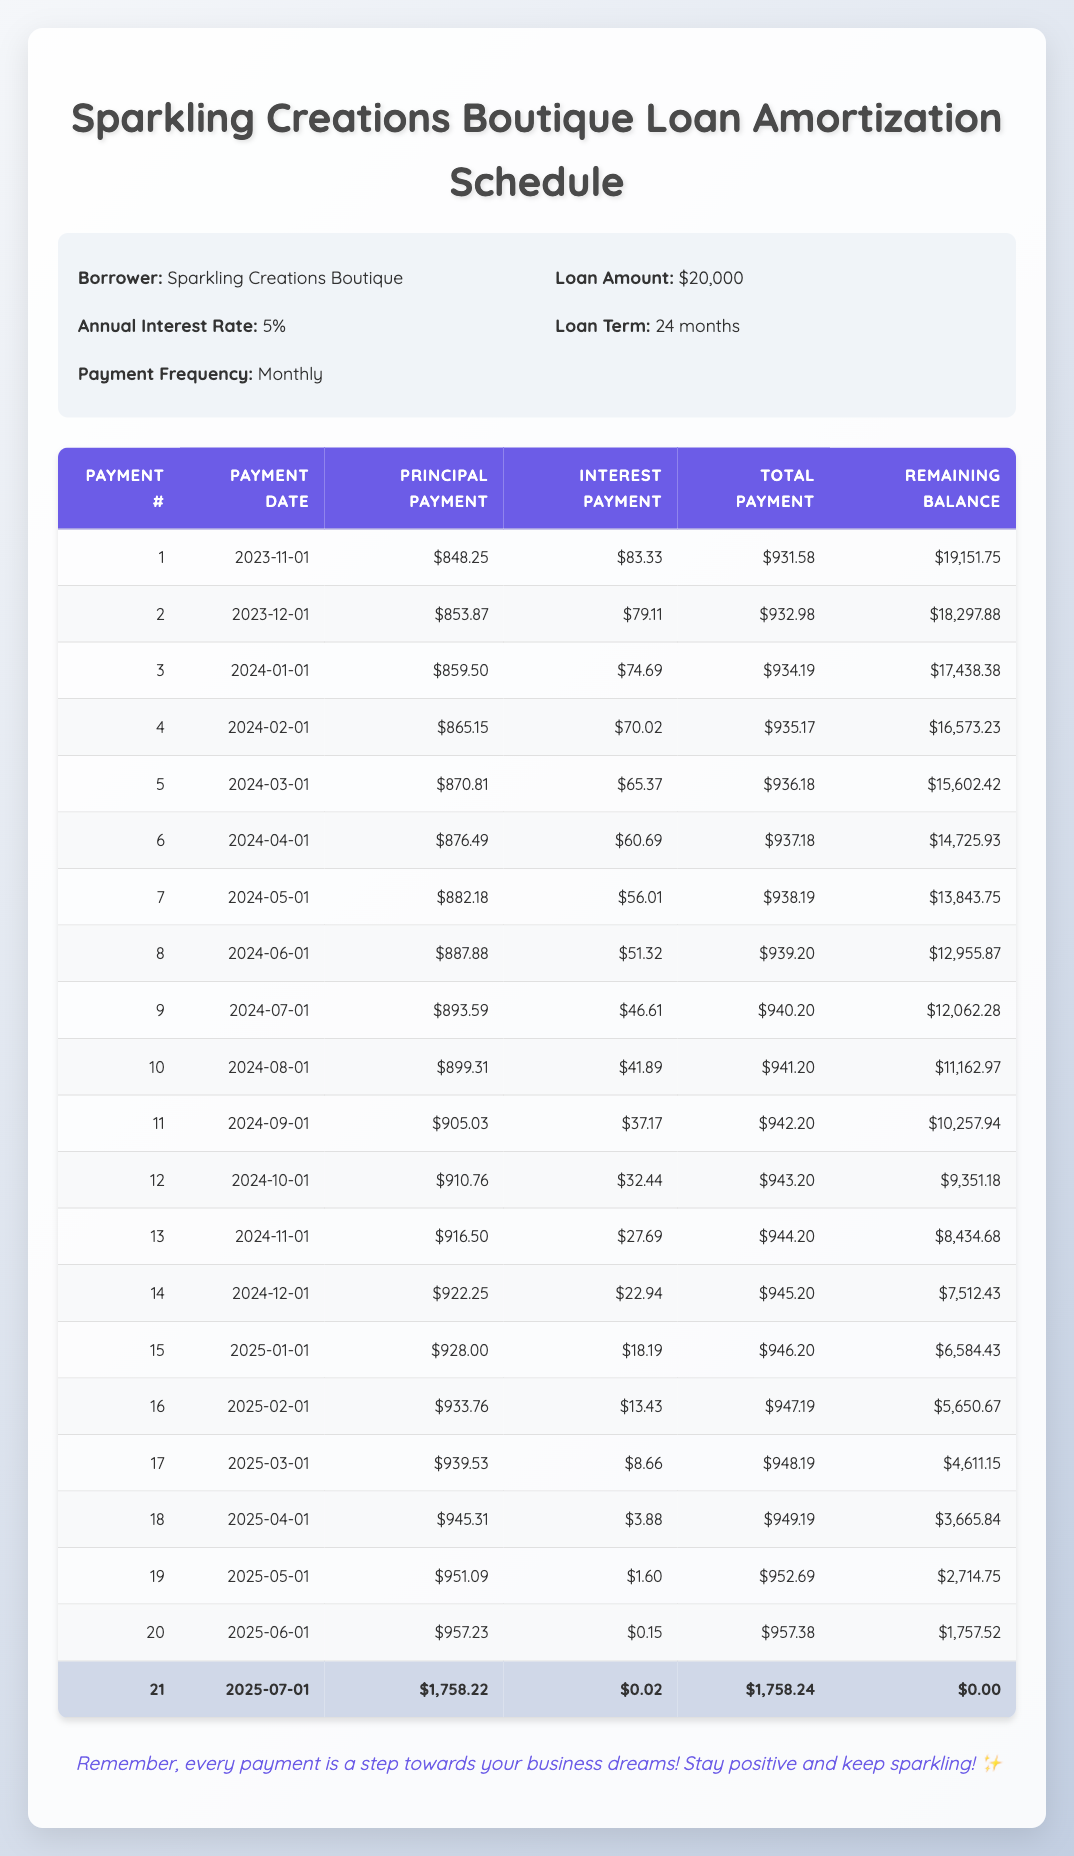What is the total amount paid after the first payment? The total payment for the first payment is $931.58, which is the value directly listed in the table for payment number 1.
Answer: 931.58 How much is the principal payment in the fifth month? The principal payment listed for the fifth month (payment number 5) is $870.81, which can be found directly in the table.
Answer: 870.81 What is the sum of the principal payments for the first three payments? To find the sum of the principal payments for the first three payments, add them together: $848.25 + $853.87 + $859.50 = $2561.62.
Answer: 2561.62 Is the interest payment for the second payment less than $80? The interest payment for the second payment is $79.11, which is less than $80.
Answer: Yes What is the remaining balance after the tenth payment? The remaining balance after the tenth payment (payment number 10) is $11,162.97, which is taken directly from the table.
Answer: 11,162.97 How much total payment was made in the 12th month compared to the 11th month? The total payment in the 12th month is $943.20 and in the 11th month is $942.20. The difference is $943.20 - $942.20 = $1, indicating that the payment increased by $1 in the 12th month compared to the 11th month.
Answer: 1 What is the average remaining balance at the end of the first six payments? To find the average remaining balance, sum the remaining balances after each of the first six payments: $19,151.75 + $18,297.88 + $17,438.38 + $16,573.23 + $15,602.42 + $14,725.93 = $101,789.59. Then divide by 6 to get the average: $101,789.59 / 6 = $16,964.93.
Answer: 16,964.93 In which payment month does the interest payment drop below $5? The interest payment drops below $5 in the 18th payment, which is $3.88 according to the data in the table.
Answer: 18th What is the total principal paid by the end of the loan term? To find the total principal paid, we take the total loan amount of $20,000 and note that it will be completely paid off by the 21st payment, indicating that the total principal paid by the end of the loan term is $20,000.
Answer: 20,000 